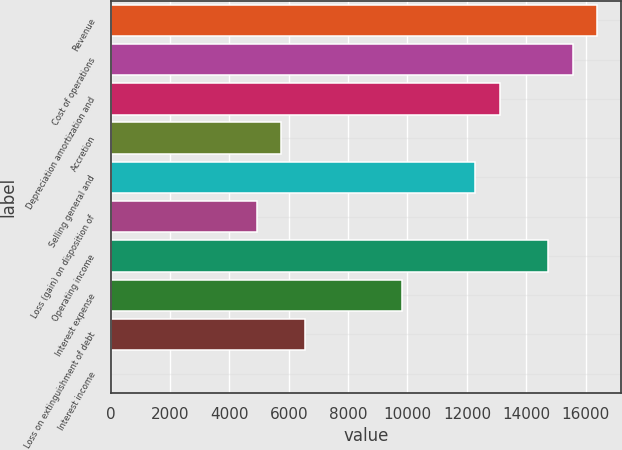<chart> <loc_0><loc_0><loc_500><loc_500><bar_chart><fcel>Revenue<fcel>Cost of operations<fcel>Depreciation amortization and<fcel>Accretion<fcel>Selling general and<fcel>Loss (gain) on disposition of<fcel>Operating income<fcel>Interest expense<fcel>Loss on extinguishment of debt<fcel>Interest income<nl><fcel>16385.5<fcel>15566.2<fcel>13108.5<fcel>5735.12<fcel>12289.2<fcel>4915.86<fcel>14747<fcel>9831.42<fcel>6554.38<fcel>0.3<nl></chart> 